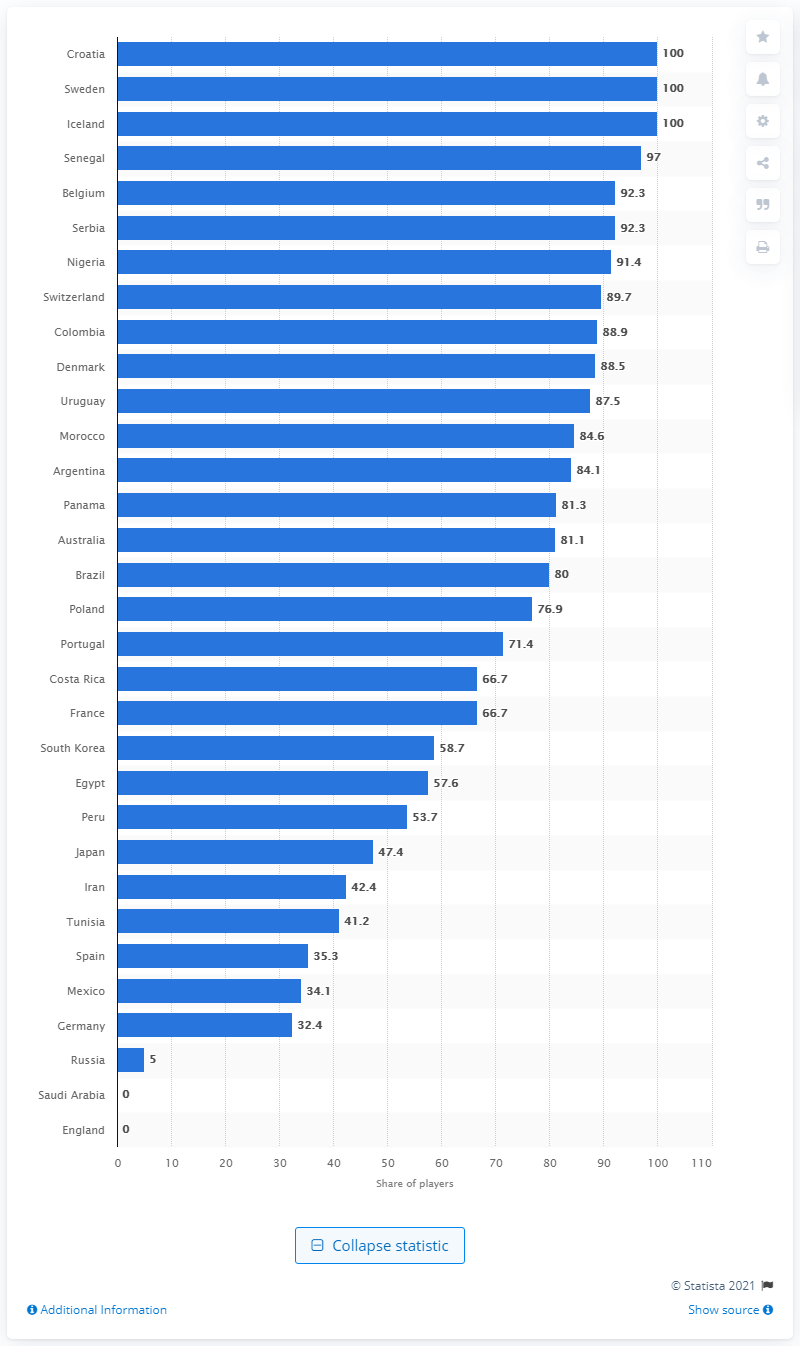Outline some significant characteristics in this image. The 2018 FIFA World Cup was held in Russia. 